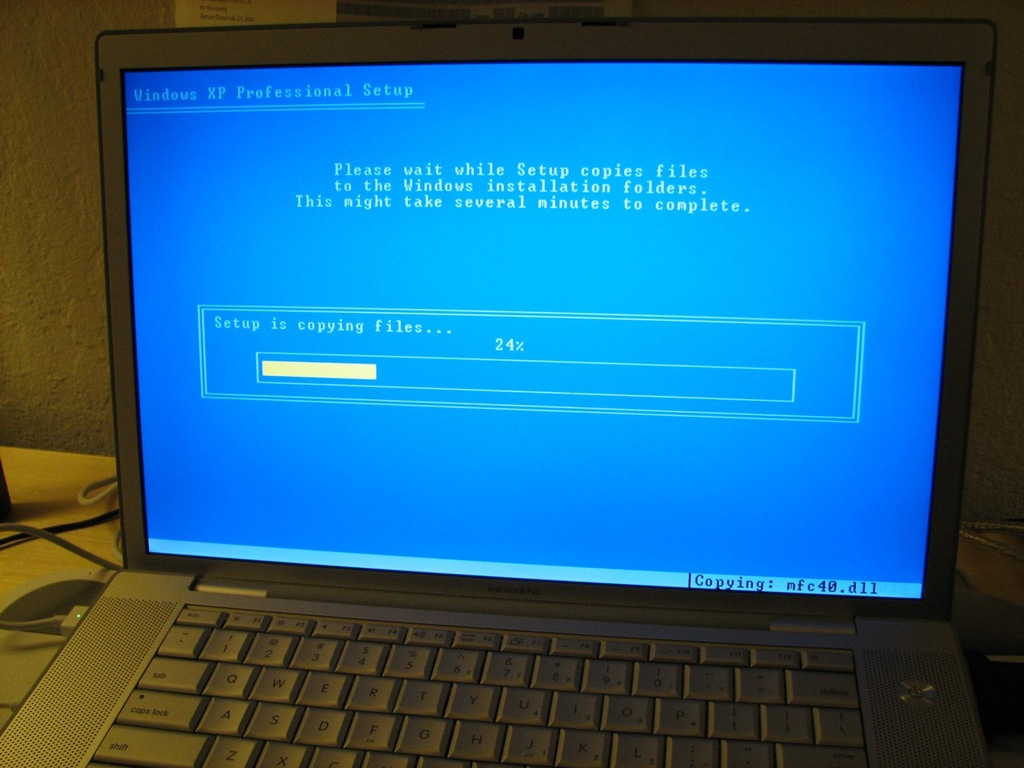How does this installation screen compare to modern operating system installations? Modern operating system installations tend to be more user-friendly and visually appealing compared to the Windows XP setup shown. They often feature sleek, minimalist interfaces with smoother animations and fewer user inputs required during the initial stages. Modern systems also typically include automatic driver updates and system checks that help streamline the process. Additionally, many systems now support installation from USB drives or even direct download installations, which are significantly faster and less prone to physical media issues. 